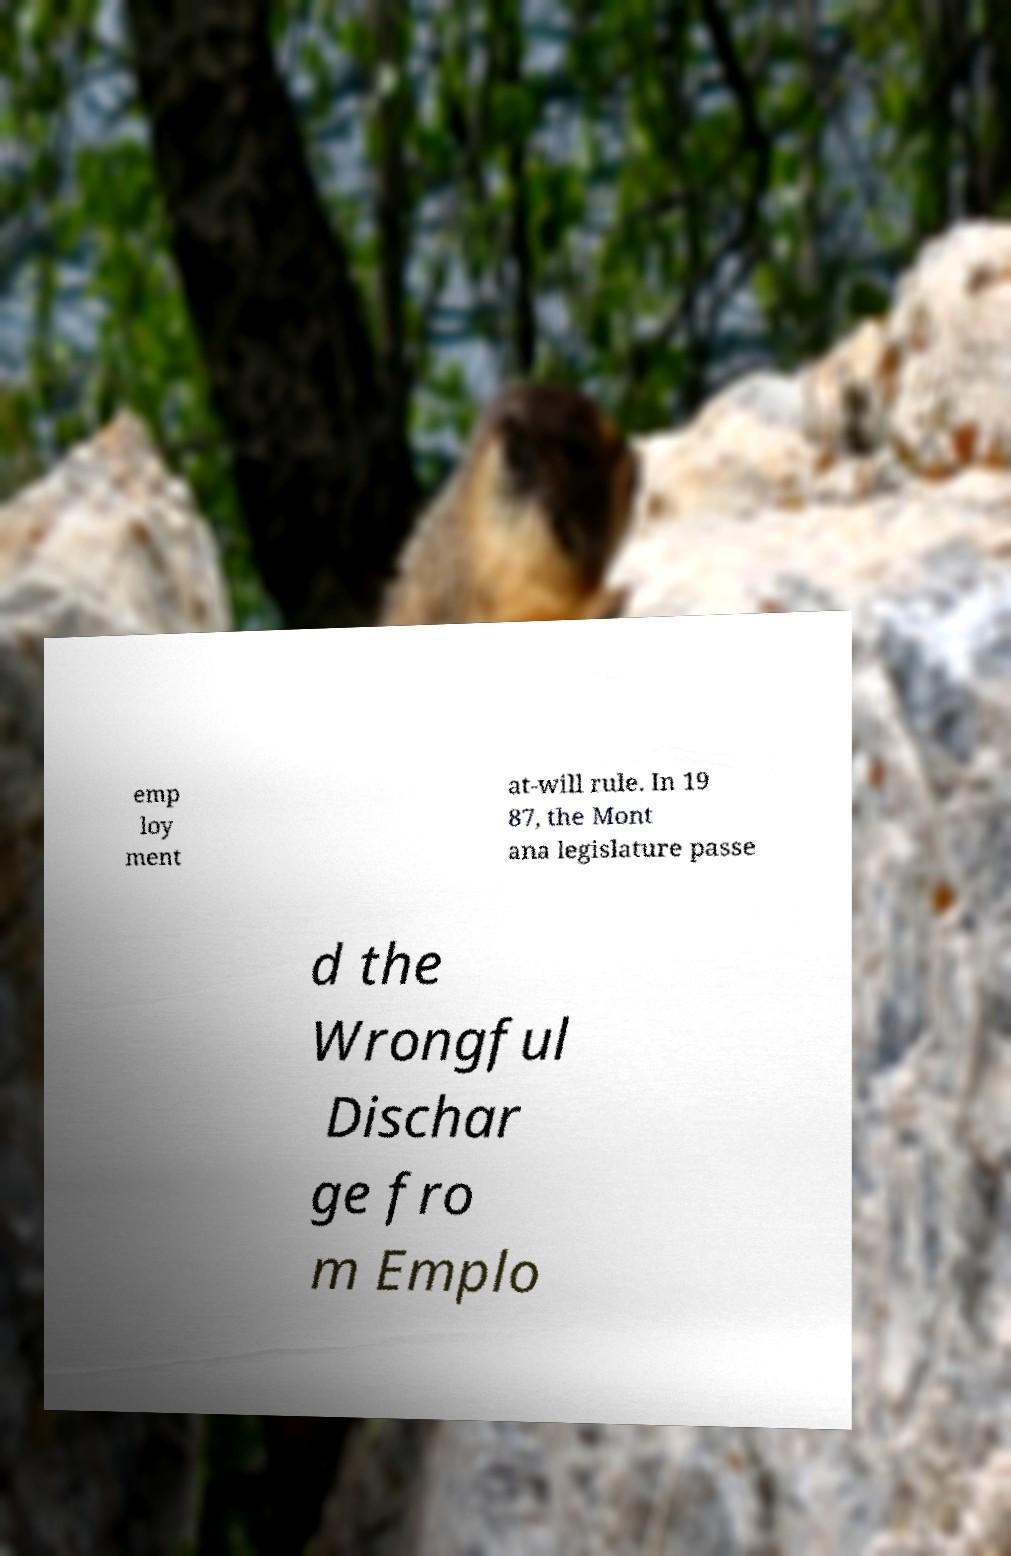For documentation purposes, I need the text within this image transcribed. Could you provide that? emp loy ment at-will rule. In 19 87, the Mont ana legislature passe d the Wrongful Dischar ge fro m Emplo 